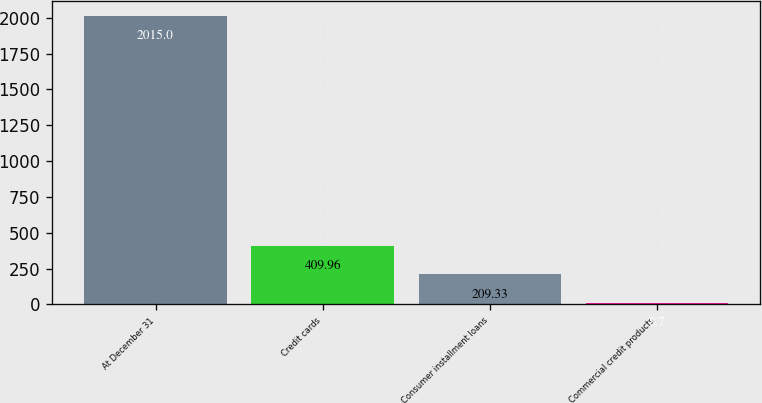Convert chart to OTSL. <chart><loc_0><loc_0><loc_500><loc_500><bar_chart><fcel>At December 31<fcel>Credit cards<fcel>Consumer installment loans<fcel>Commercial credit products<nl><fcel>2015<fcel>409.96<fcel>209.33<fcel>8.7<nl></chart> 